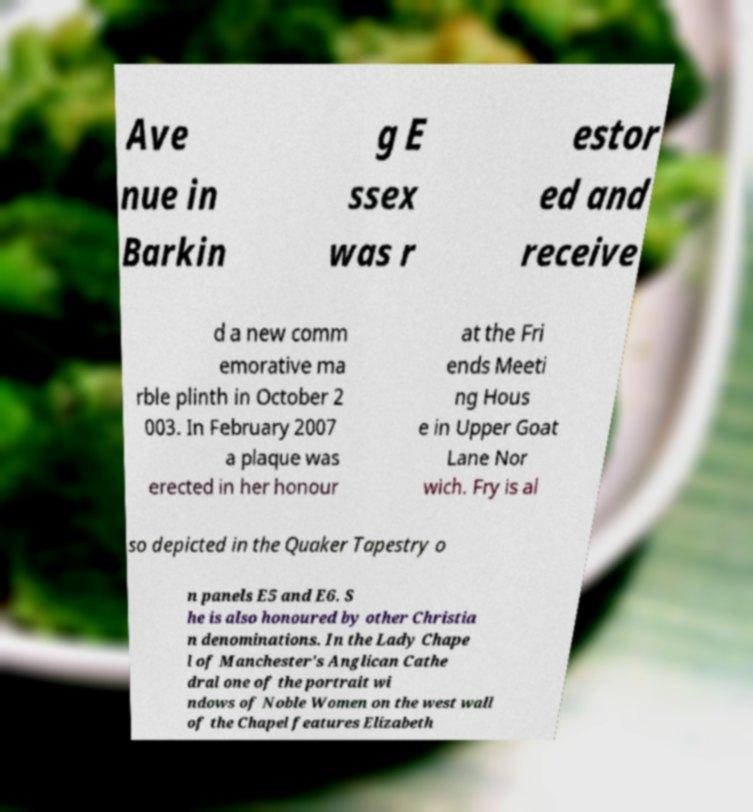I need the written content from this picture converted into text. Can you do that? Ave nue in Barkin g E ssex was r estor ed and receive d a new comm emorative ma rble plinth in October 2 003. In February 2007 a plaque was erected in her honour at the Fri ends Meeti ng Hous e in Upper Goat Lane Nor wich. Fry is al so depicted in the Quaker Tapestry o n panels E5 and E6. S he is also honoured by other Christia n denominations. In the Lady Chape l of Manchester's Anglican Cathe dral one of the portrait wi ndows of Noble Women on the west wall of the Chapel features Elizabeth 